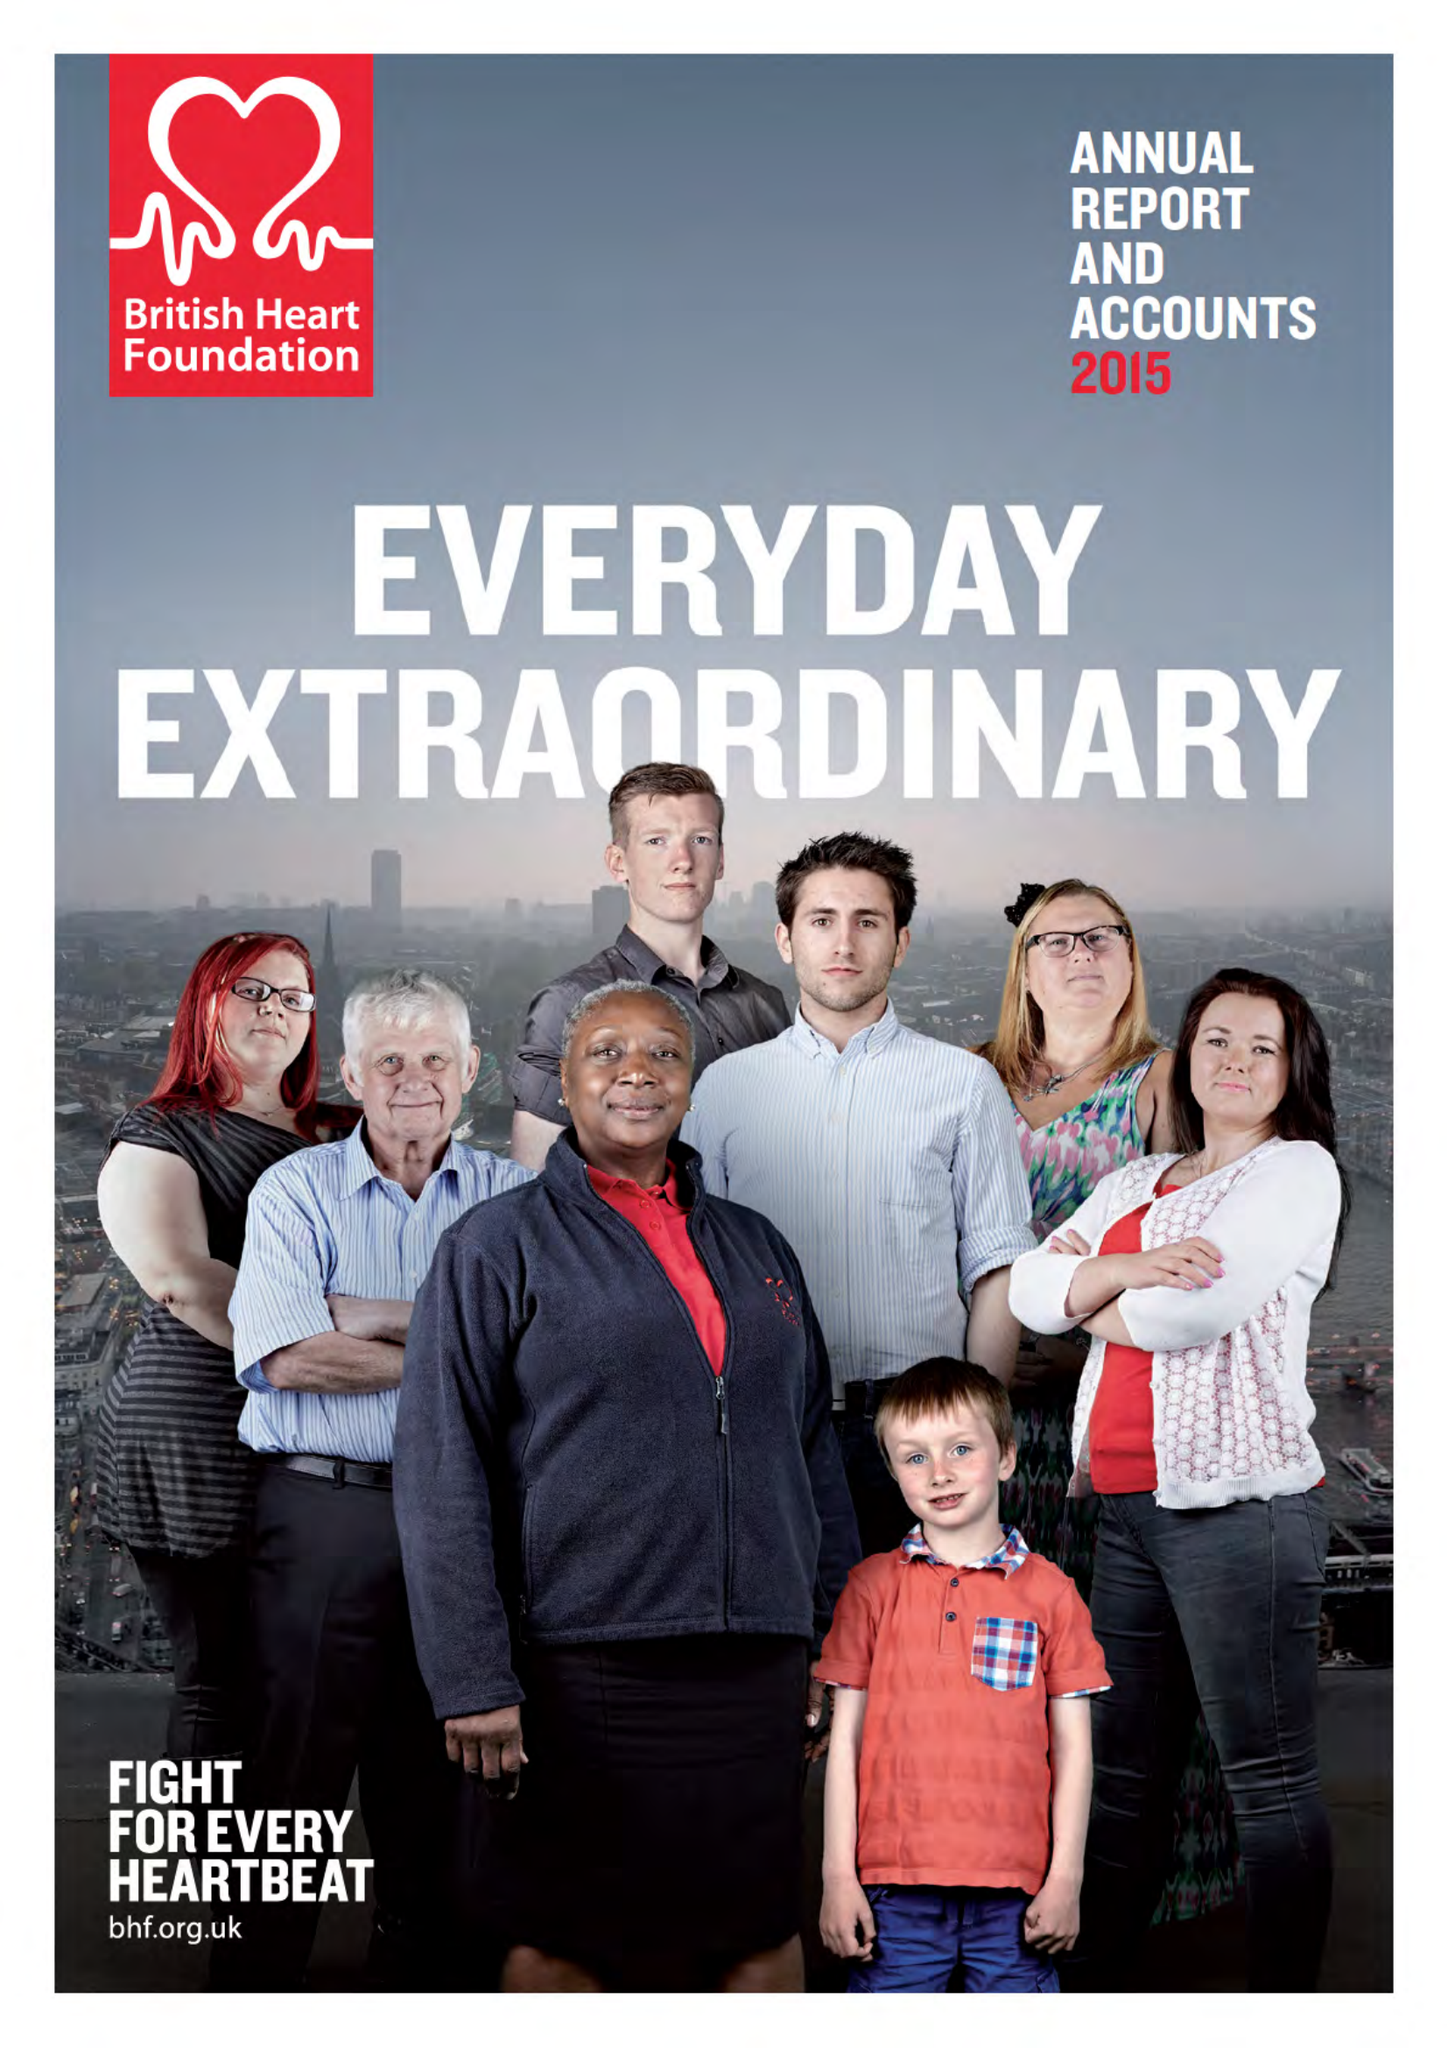What is the value for the report_date?
Answer the question using a single word or phrase. 2015-03-31 